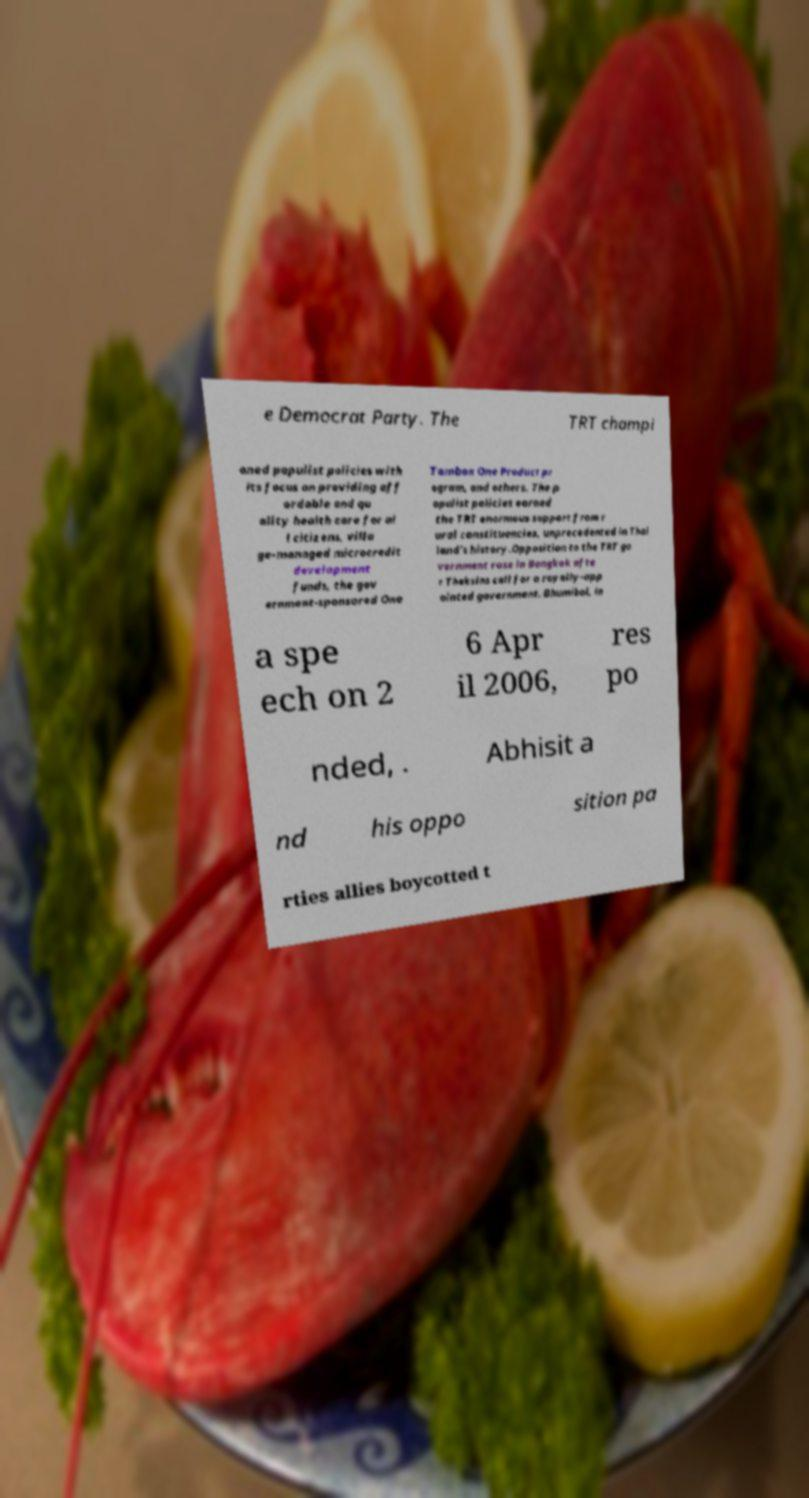For documentation purposes, I need the text within this image transcribed. Could you provide that? e Democrat Party. The TRT champi oned populist policies with its focus on providing aff ordable and qu ality health care for al l citizens, villa ge-managed microcredit development funds, the gov ernment-sponsored One Tambon One Product pr ogram, and others. The p opulist policies earned the TRT enormous support from r ural constituencies, unprecedented in Thai land's history.Opposition to the TRT go vernment rose in Bangkok afte r Thaksins call for a royally-app ointed government. Bhumibol, in a spe ech on 2 6 Apr il 2006, res po nded, . Abhisit a nd his oppo sition pa rties allies boycotted t 